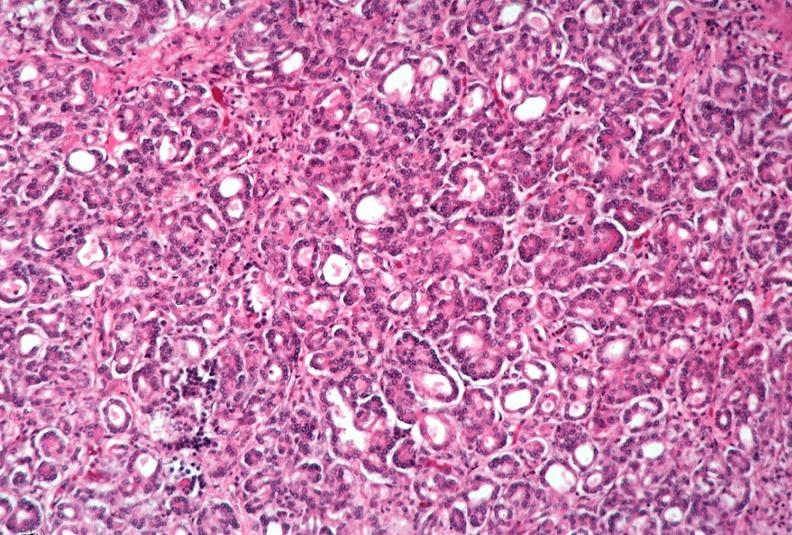where is this?
Answer the question using a single word or phrase. Pancreas 